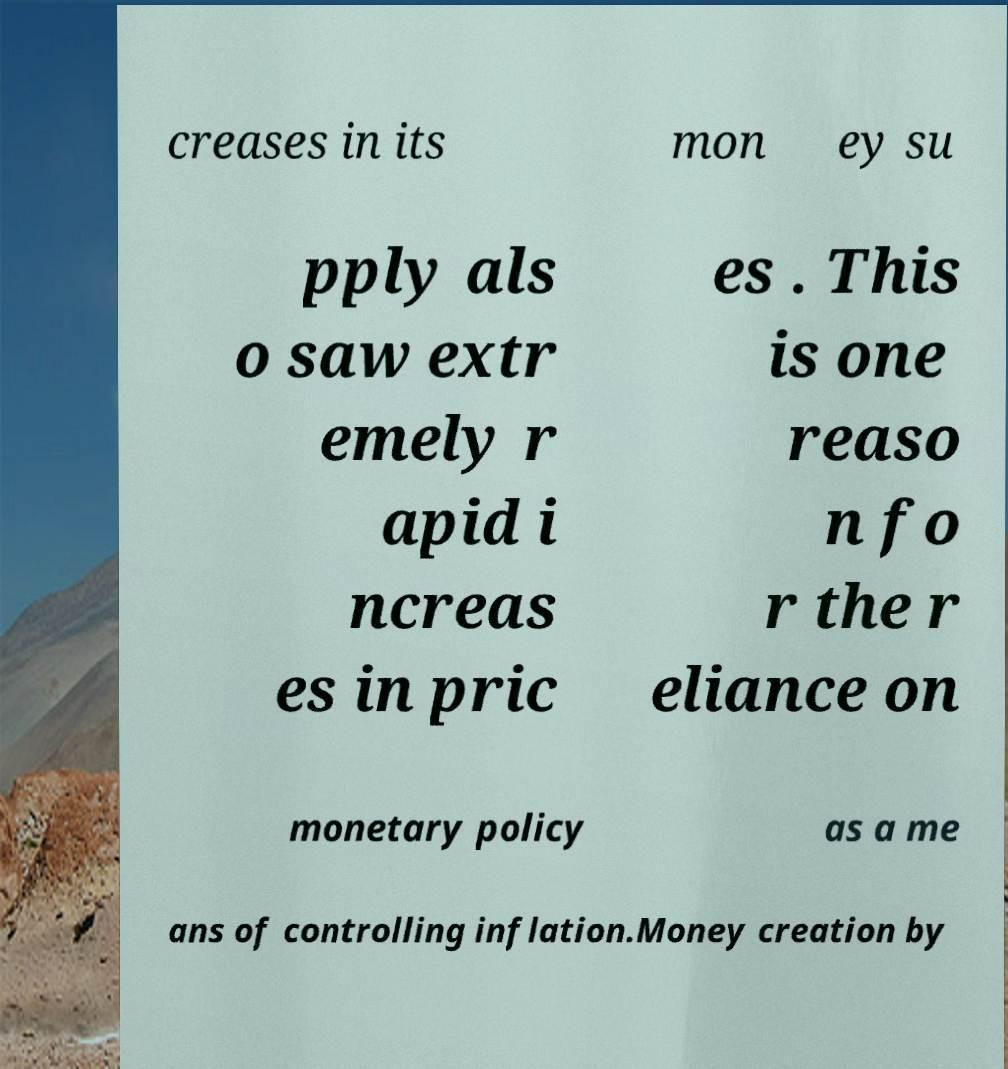Can you accurately transcribe the text from the provided image for me? creases in its mon ey su pply als o saw extr emely r apid i ncreas es in pric es . This is one reaso n fo r the r eliance on monetary policy as a me ans of controlling inflation.Money creation by 